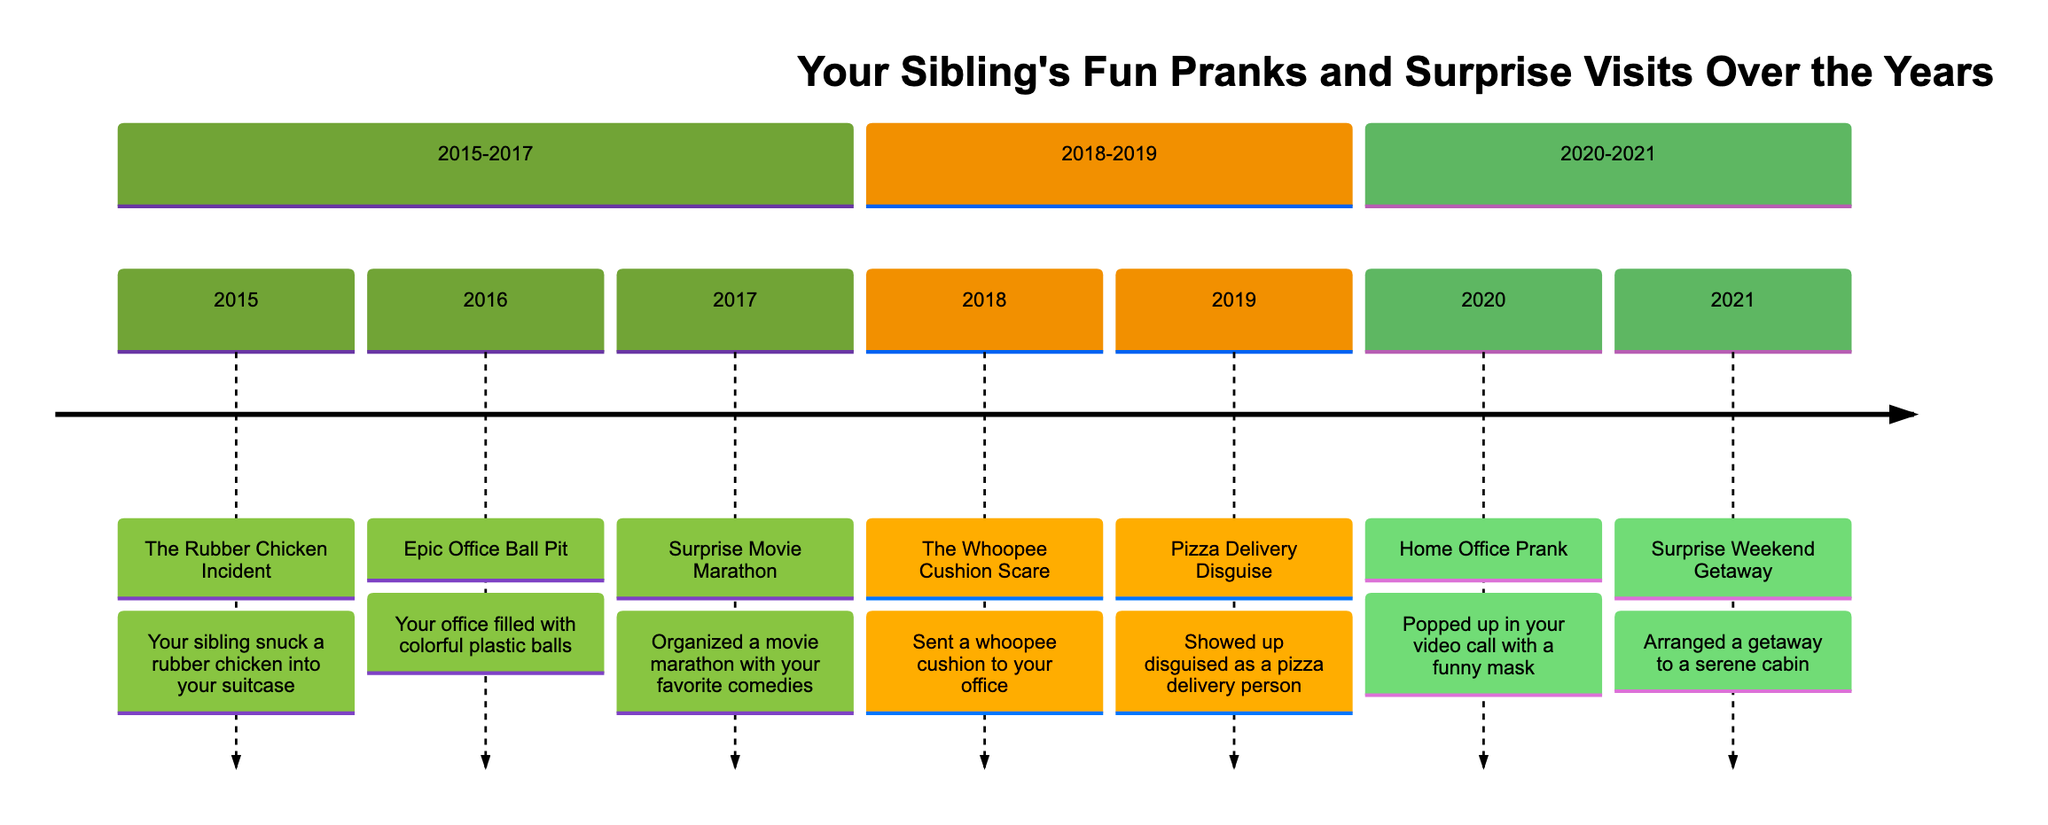What was the first event in the timeline? The first event listed is "The Rubber Chicken Incident" occurring in 2015.
Answer: The Rubber Chicken Incident How many events are documented from 2015 to 2017? From 2015 to 2017, there are three events: The Rubber Chicken Incident, Epic Office Ball Pit, and Surprise Movie Marathon.
Answer: 3 Which year did the "Surprise Weekend Getaway" take place? The "Surprise Weekend Getaway" happened in 2021, which is the last event listed in the timeline.
Answer: 2021 What prank involved a whoopee cushion? The event labeled "The Whoopee Cushion Scare" in 2018 involved sending a whoopee cushion to your office.
Answer: The Whoopee Cushion Scare Which events involve surprise visits from your sibling? The two events that involve surprise visits are "Surprise Movie Marathon" in 2017 and "Pizza Delivery Disguise" in 2019.
Answer: Surprise Movie Marathon, Pizza Delivery Disguise In which year did your office fill with colorful plastic balls? The event "Epic Office Ball Pit" occurred in 2016 when your office was filled with colorful plastic balls.
Answer: 2016 What is the last event mentioned in the timeline? The last event mentioned is "Surprise Weekend Getaway," which took place in 2021.
Answer: Surprise Weekend Getaway How many pranks were executed in the timeline? The timeline shows four prank events: The Rubber Chicken Incident, Epic Office Ball Pit, The Whoopee Cushion Scare, and Home Office Prank.
Answer: 4 Which year witnessed a surprise movie marathon? The surprise movie marathon occurred in 2017, per the event details in the timeline.
Answer: 2017 